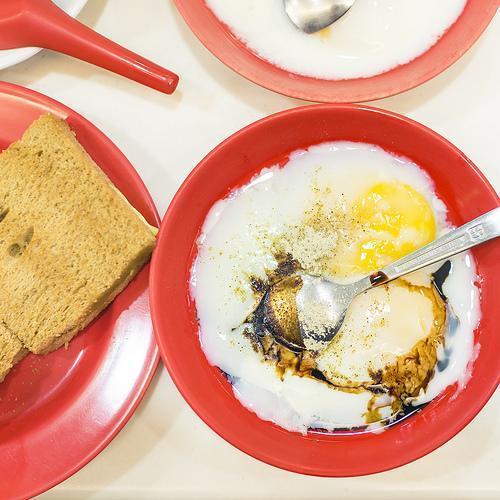How many bowls are there?
Give a very brief answer. 2. How many slices are on the plate?
Give a very brief answer. 2. 